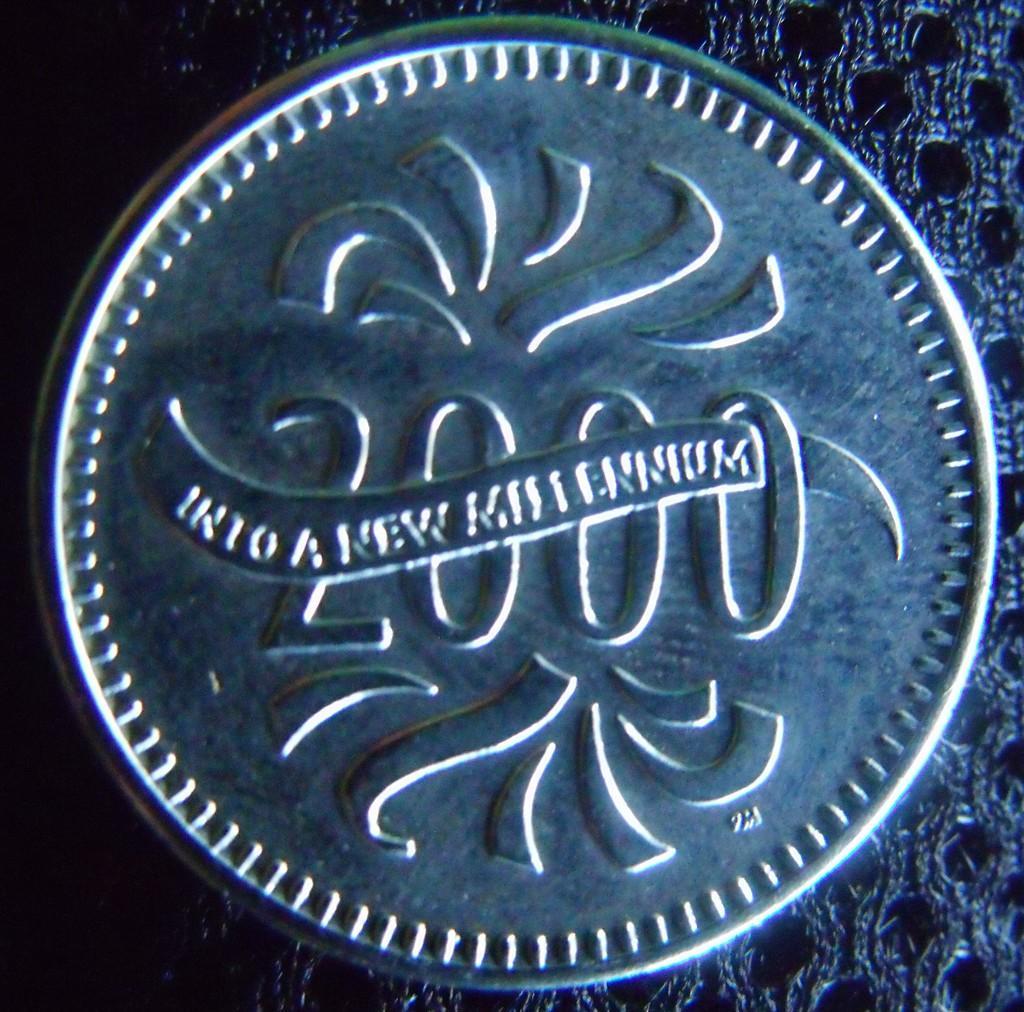Please provide a concise description of this image. In the image there is a coin with number and there is something written on it. And also there is a design on it. 